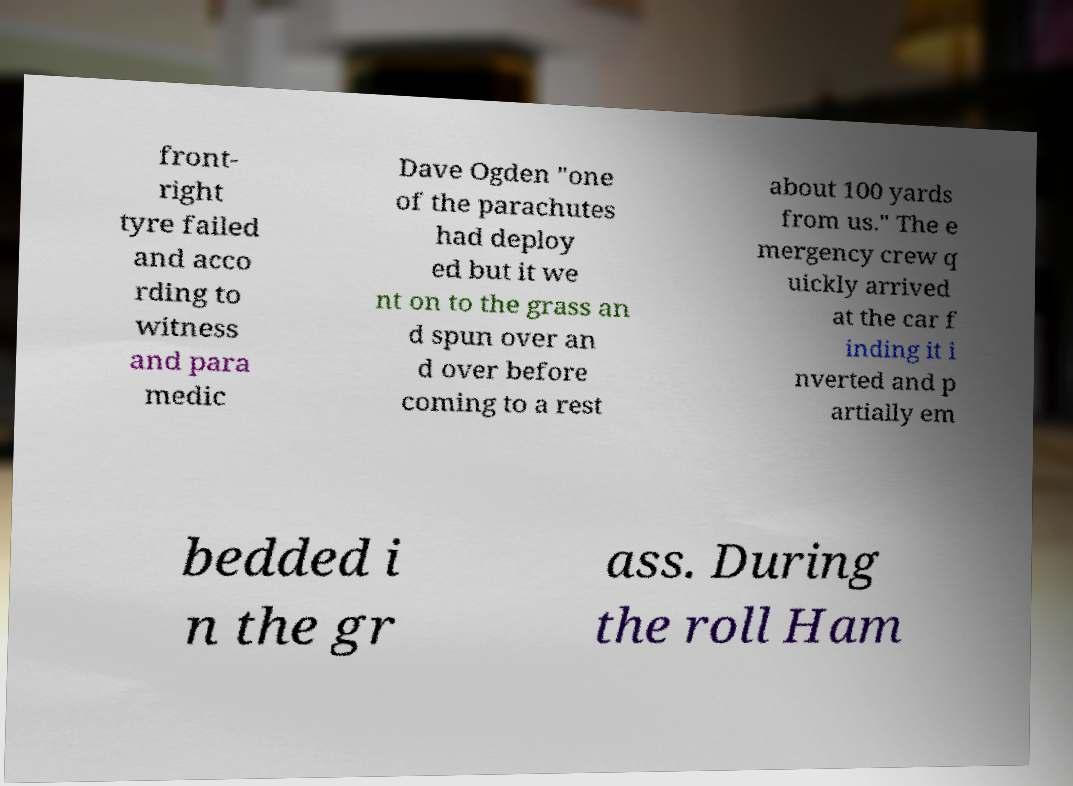Can you accurately transcribe the text from the provided image for me? front- right tyre failed and acco rding to witness and para medic Dave Ogden "one of the parachutes had deploy ed but it we nt on to the grass an d spun over an d over before coming to a rest about 100 yards from us." The e mergency crew q uickly arrived at the car f inding it i nverted and p artially em bedded i n the gr ass. During the roll Ham 